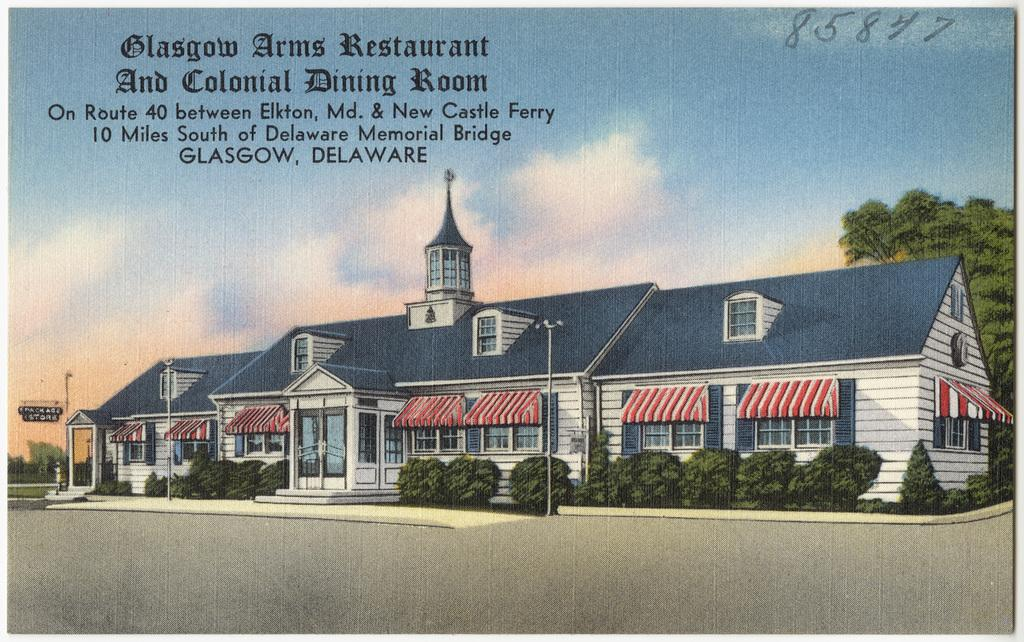What is present in the image that has writing on it? There is a poster in the image, and something is written on it. What type of structure can be seen in the image? There is a building in the image. What type of vegetation is present in the image? There are plants and trees in the image. What type of vertical structures are present in the image? There are poles in the image. What is the condition of the sky in the image? The sky is cloudy in the image. What type of flat, rigid surfaces are present in the image? There are boards in the image. What type of objects are present in the image? There are objects in the image. What type of appliance is being used by the slave in the image? There is no appliance or slave present in the image. What type of chair is visible in the image? There is no chair present in the image. 